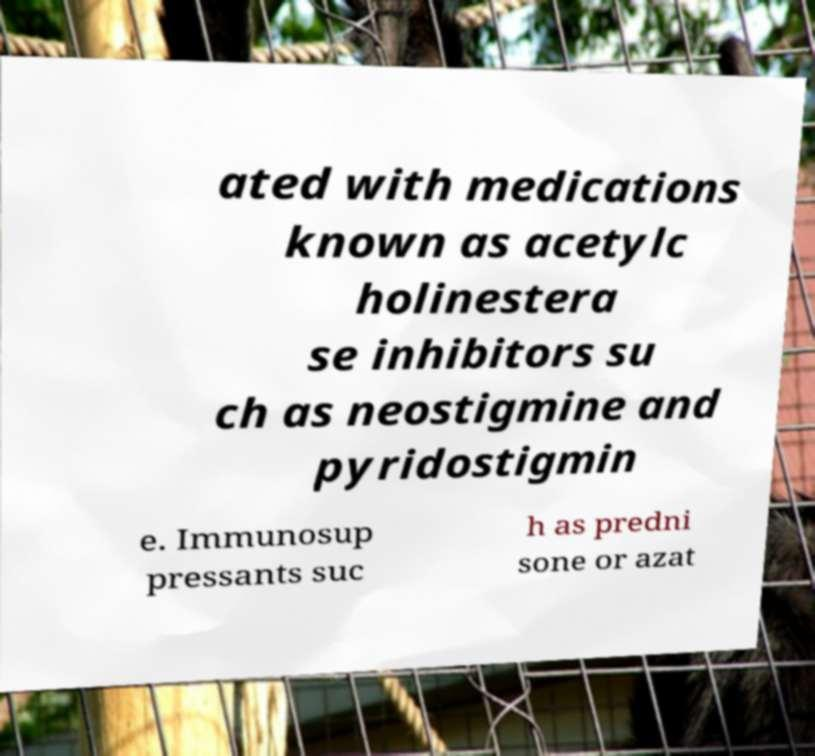Could you extract and type out the text from this image? ated with medications known as acetylc holinestera se inhibitors su ch as neostigmine and pyridostigmin e. Immunosup pressants suc h as predni sone or azat 